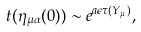Convert formula to latex. <formula><loc_0><loc_0><loc_500><loc_500>t ( \eta _ { \mu \alpha } ( 0 ) ) \sim e ^ { a \epsilon \tau ( Y _ { \mu } ) } ,</formula> 